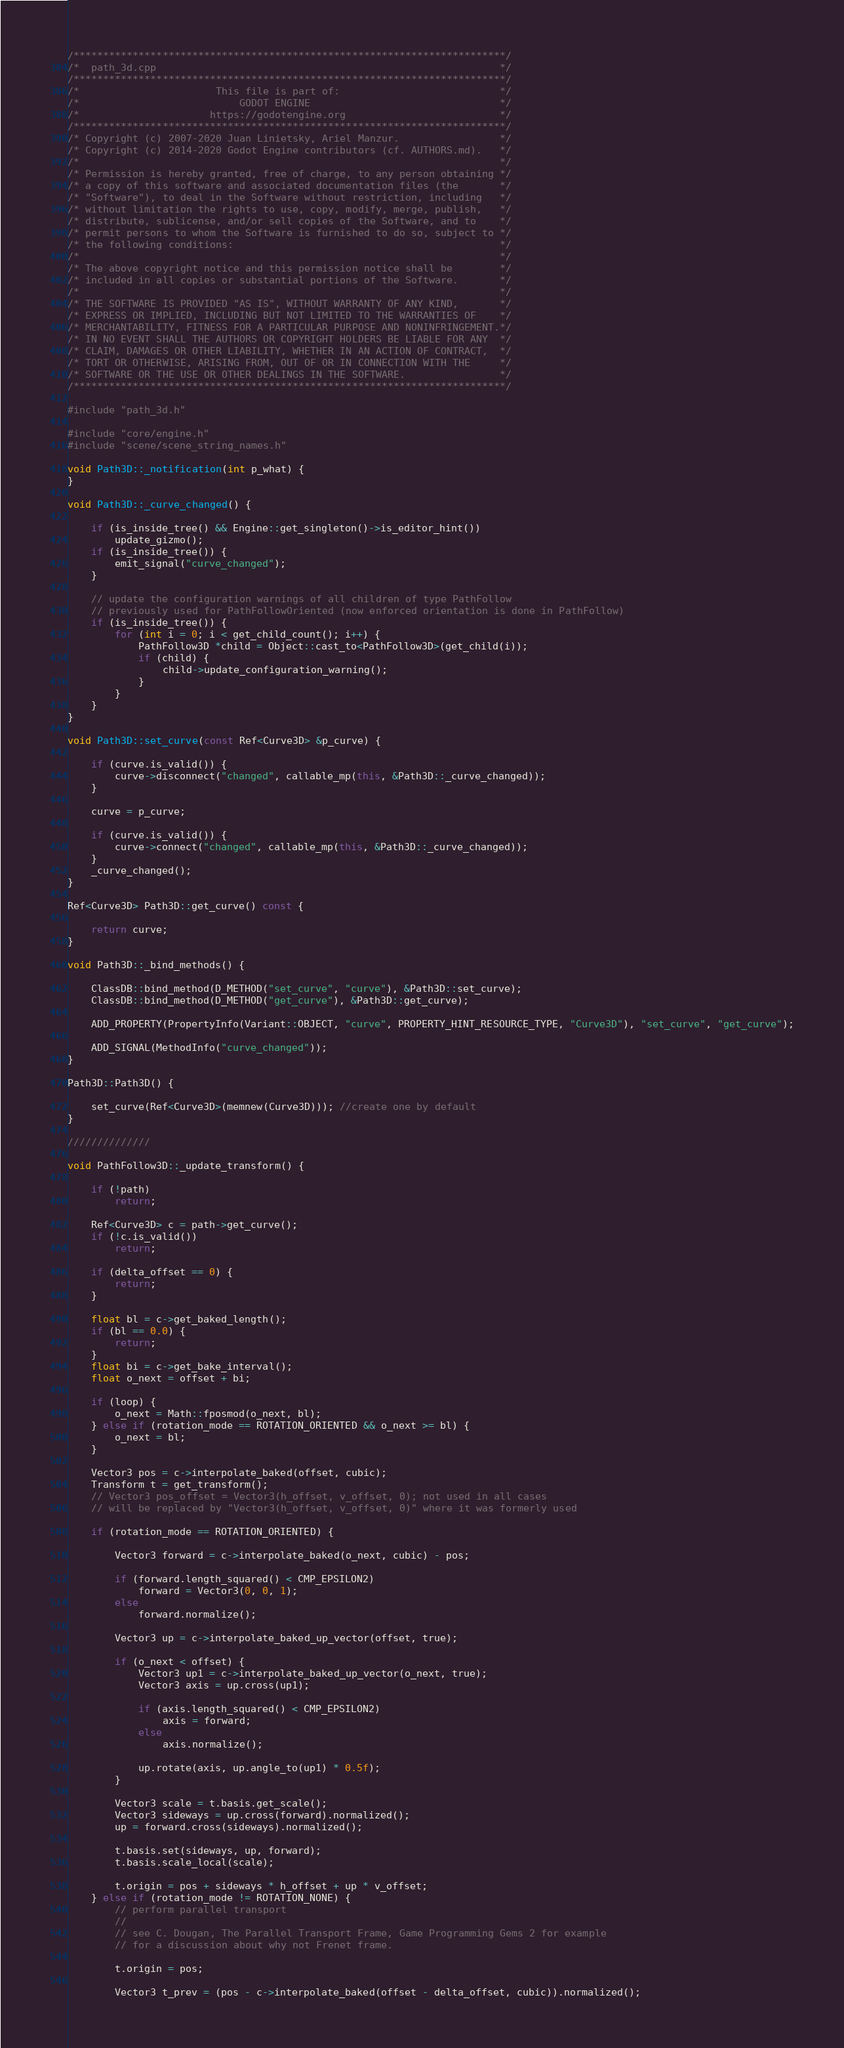<code> <loc_0><loc_0><loc_500><loc_500><_C++_>/*************************************************************************/
/*  path_3d.cpp                                                          */
/*************************************************************************/
/*                       This file is part of:                           */
/*                           GODOT ENGINE                                */
/*                      https://godotengine.org                          */
/*************************************************************************/
/* Copyright (c) 2007-2020 Juan Linietsky, Ariel Manzur.                 */
/* Copyright (c) 2014-2020 Godot Engine contributors (cf. AUTHORS.md).   */
/*                                                                       */
/* Permission is hereby granted, free of charge, to any person obtaining */
/* a copy of this software and associated documentation files (the       */
/* "Software"), to deal in the Software without restriction, including   */
/* without limitation the rights to use, copy, modify, merge, publish,   */
/* distribute, sublicense, and/or sell copies of the Software, and to    */
/* permit persons to whom the Software is furnished to do so, subject to */
/* the following conditions:                                             */
/*                                                                       */
/* The above copyright notice and this permission notice shall be        */
/* included in all copies or substantial portions of the Software.       */
/*                                                                       */
/* THE SOFTWARE IS PROVIDED "AS IS", WITHOUT WARRANTY OF ANY KIND,       */
/* EXPRESS OR IMPLIED, INCLUDING BUT NOT LIMITED TO THE WARRANTIES OF    */
/* MERCHANTABILITY, FITNESS FOR A PARTICULAR PURPOSE AND NONINFRINGEMENT.*/
/* IN NO EVENT SHALL THE AUTHORS OR COPYRIGHT HOLDERS BE LIABLE FOR ANY  */
/* CLAIM, DAMAGES OR OTHER LIABILITY, WHETHER IN AN ACTION OF CONTRACT,  */
/* TORT OR OTHERWISE, ARISING FROM, OUT OF OR IN CONNECTION WITH THE     */
/* SOFTWARE OR THE USE OR OTHER DEALINGS IN THE SOFTWARE.                */
/*************************************************************************/

#include "path_3d.h"

#include "core/engine.h"
#include "scene/scene_string_names.h"

void Path3D::_notification(int p_what) {
}

void Path3D::_curve_changed() {

	if (is_inside_tree() && Engine::get_singleton()->is_editor_hint())
		update_gizmo();
	if (is_inside_tree()) {
		emit_signal("curve_changed");
	}

	// update the configuration warnings of all children of type PathFollow
	// previously used for PathFollowOriented (now enforced orientation is done in PathFollow)
	if (is_inside_tree()) {
		for (int i = 0; i < get_child_count(); i++) {
			PathFollow3D *child = Object::cast_to<PathFollow3D>(get_child(i));
			if (child) {
				child->update_configuration_warning();
			}
		}
	}
}

void Path3D::set_curve(const Ref<Curve3D> &p_curve) {

	if (curve.is_valid()) {
		curve->disconnect("changed", callable_mp(this, &Path3D::_curve_changed));
	}

	curve = p_curve;

	if (curve.is_valid()) {
		curve->connect("changed", callable_mp(this, &Path3D::_curve_changed));
	}
	_curve_changed();
}

Ref<Curve3D> Path3D::get_curve() const {

	return curve;
}

void Path3D::_bind_methods() {

	ClassDB::bind_method(D_METHOD("set_curve", "curve"), &Path3D::set_curve);
	ClassDB::bind_method(D_METHOD("get_curve"), &Path3D::get_curve);

	ADD_PROPERTY(PropertyInfo(Variant::OBJECT, "curve", PROPERTY_HINT_RESOURCE_TYPE, "Curve3D"), "set_curve", "get_curve");

	ADD_SIGNAL(MethodInfo("curve_changed"));
}

Path3D::Path3D() {

	set_curve(Ref<Curve3D>(memnew(Curve3D))); //create one by default
}

//////////////

void PathFollow3D::_update_transform() {

	if (!path)
		return;

	Ref<Curve3D> c = path->get_curve();
	if (!c.is_valid())
		return;

	if (delta_offset == 0) {
		return;
	}

	float bl = c->get_baked_length();
	if (bl == 0.0) {
		return;
	}
	float bi = c->get_bake_interval();
	float o_next = offset + bi;

	if (loop) {
		o_next = Math::fposmod(o_next, bl);
	} else if (rotation_mode == ROTATION_ORIENTED && o_next >= bl) {
		o_next = bl;
	}

	Vector3 pos = c->interpolate_baked(offset, cubic);
	Transform t = get_transform();
	// Vector3 pos_offset = Vector3(h_offset, v_offset, 0); not used in all cases
	// will be replaced by "Vector3(h_offset, v_offset, 0)" where it was formerly used

	if (rotation_mode == ROTATION_ORIENTED) {

		Vector3 forward = c->interpolate_baked(o_next, cubic) - pos;

		if (forward.length_squared() < CMP_EPSILON2)
			forward = Vector3(0, 0, 1);
		else
			forward.normalize();

		Vector3 up = c->interpolate_baked_up_vector(offset, true);

		if (o_next < offset) {
			Vector3 up1 = c->interpolate_baked_up_vector(o_next, true);
			Vector3 axis = up.cross(up1);

			if (axis.length_squared() < CMP_EPSILON2)
				axis = forward;
			else
				axis.normalize();

			up.rotate(axis, up.angle_to(up1) * 0.5f);
		}

		Vector3 scale = t.basis.get_scale();
		Vector3 sideways = up.cross(forward).normalized();
		up = forward.cross(sideways).normalized();

		t.basis.set(sideways, up, forward);
		t.basis.scale_local(scale);

		t.origin = pos + sideways * h_offset + up * v_offset;
	} else if (rotation_mode != ROTATION_NONE) {
		// perform parallel transport
		//
		// see C. Dougan, The Parallel Transport Frame, Game Programming Gems 2 for example
		// for a discussion about why not Frenet frame.

		t.origin = pos;

		Vector3 t_prev = (pos - c->interpolate_baked(offset - delta_offset, cubic)).normalized();</code> 